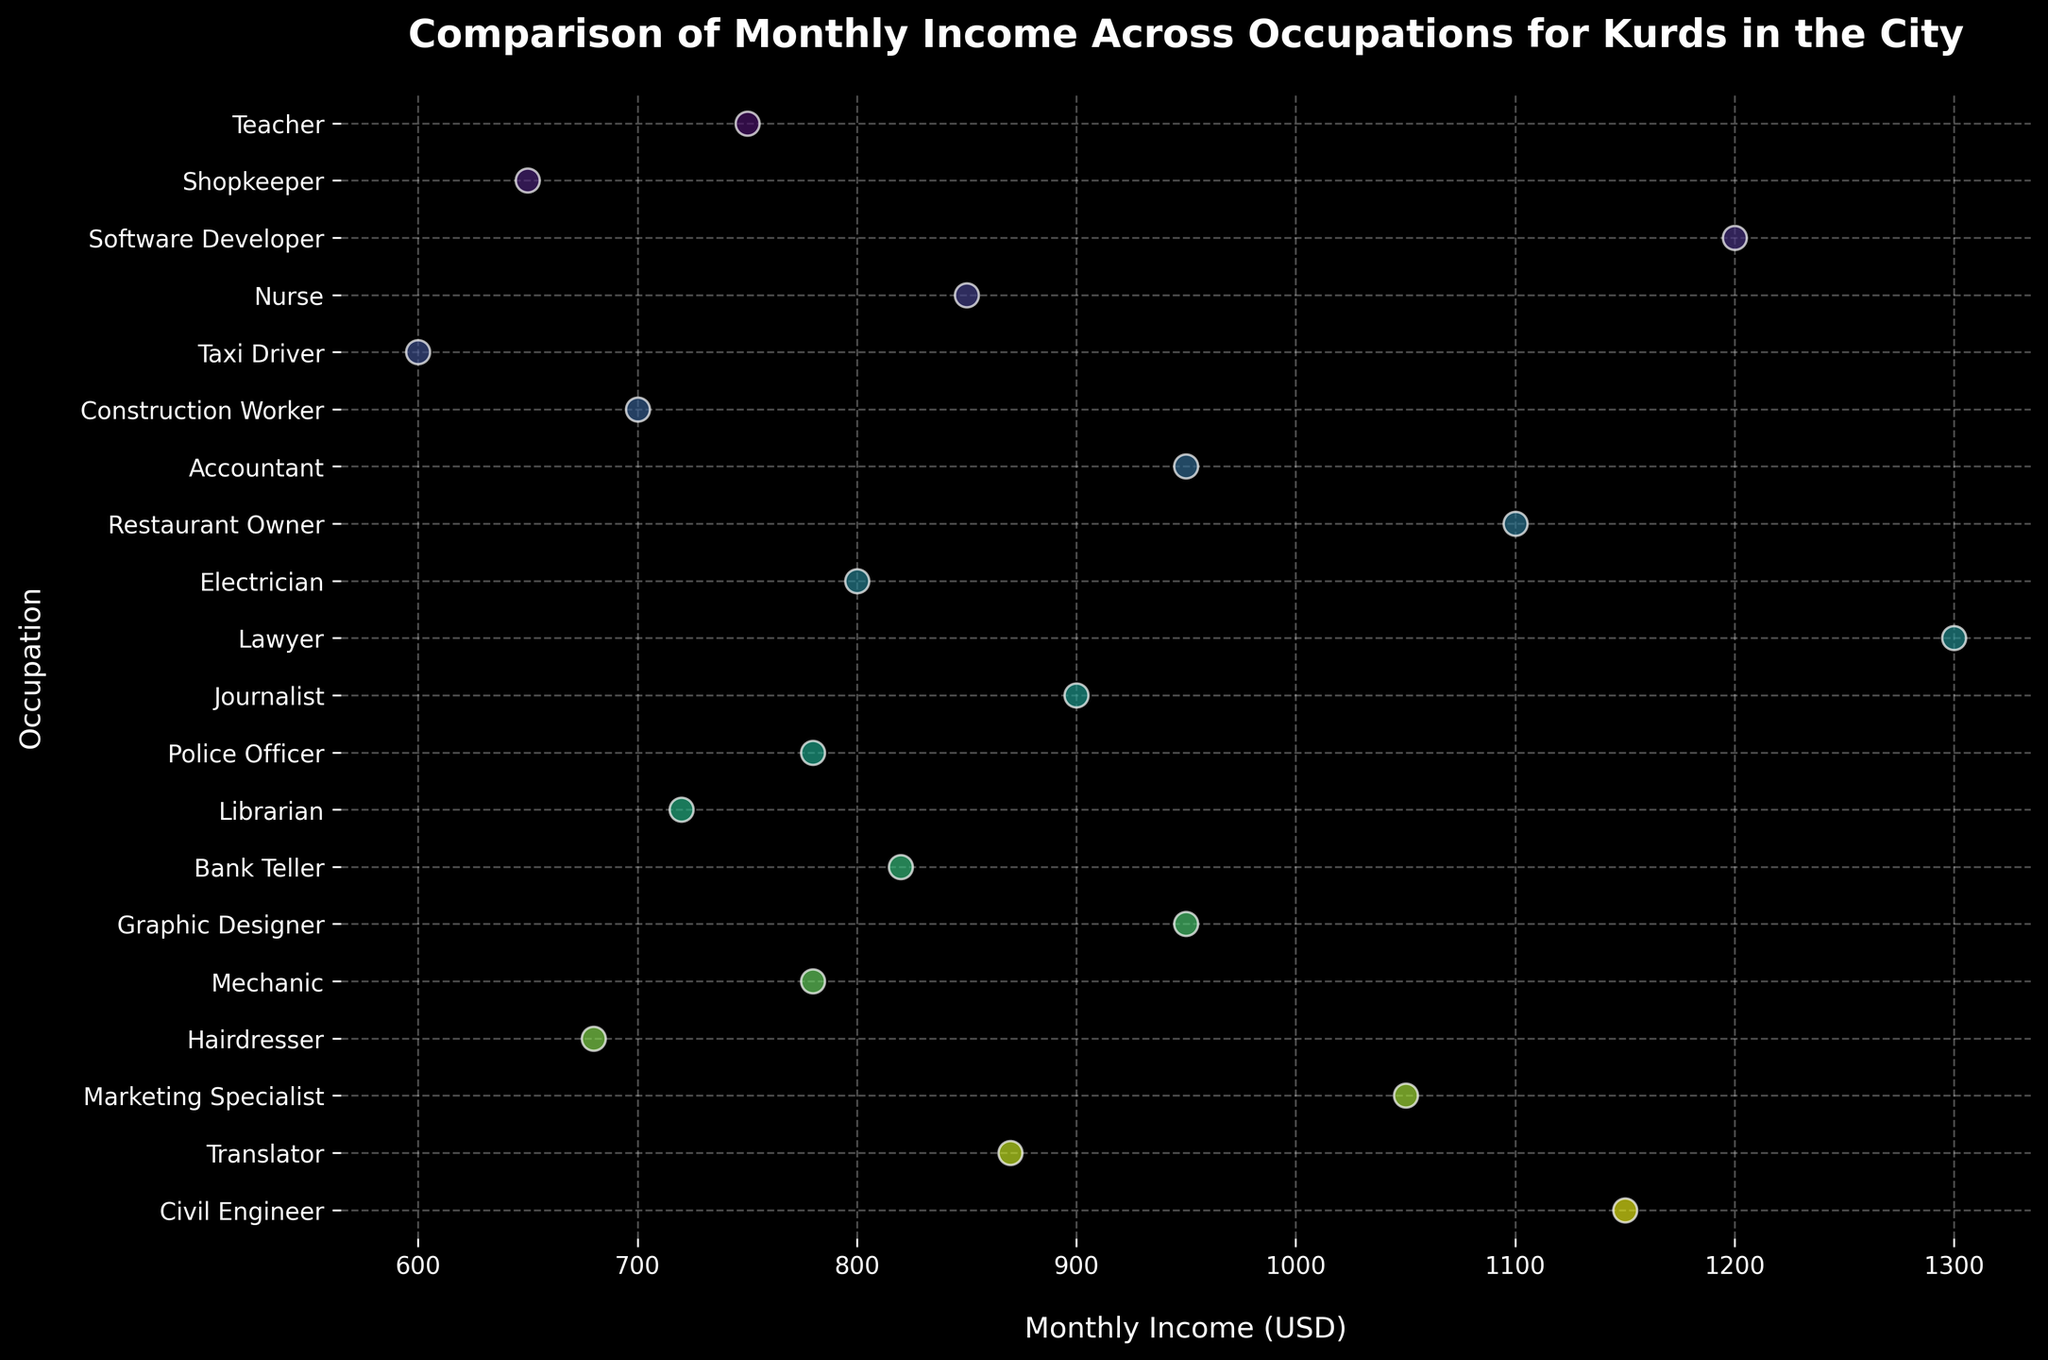Which occupation has the highest monthly income? The plot shows income levels for each occupation, and the highest point on the x-axis corresponds to the Lawyer, indicating the highest monthly income.
Answer: Lawyer What is the average monthly income for the given occupations? To find the average, add all the listed incomes: (750+650+1200+850+600+700+950+1100+800+1300+900+780+720+820+950+780+680+1050+870+1150) = 18900, then divide by the number of occupations, 20: (18900/20).
Answer: 945 How many occupations have a monthly income above $1000? Identify all occupations with income marks above 1000 on the plot: Software Developer, Restaurant Owner, Lawyer, Marketing Specialist, Civil Engineer.
Answer: 5 Which occupation has a lower monthly income, Mechanic or Nurse? Compare positions on the x-axis for Mechanic (780 USD) and Nurse (850 USD). Mechanic's income point lies to the left.
Answer: Mechanic What is the median monthly income among the occupations? Arrange all incomes in ascending order, find the middle value (or average the two middle values for an even number of data points). The middle values are 850 and 870, so the median is (850+870)/2.
Answer: 860 Which two occupations have incomes closest to each other? Look for occupations whose points are closest on the x-axis. Here, Mechanic (780 USD) and Police Officer (780 USD) have identical incomes.
Answer: Mechanic and Police Officer Is there a wider spread of incomes among skilled labor or professional occupations? Compare the range of income's x-axis points for skilled labor (e.g., Taxi Driver, Construction Worker) and professional (e.g., Lawyer, Software Developer). Professionals show a larger spread from 750 to 1300 USD.
Answer: Professional occupations What profession is located directly at the $900 mark? Check the occupation corresponding to the vertical position level with the $900 mark.
Answer: Journalist Name an occupation with a monthly income of $1100. Identify the point exactly at $1100 on the x-axis.
Answer: Restaurant Owner 